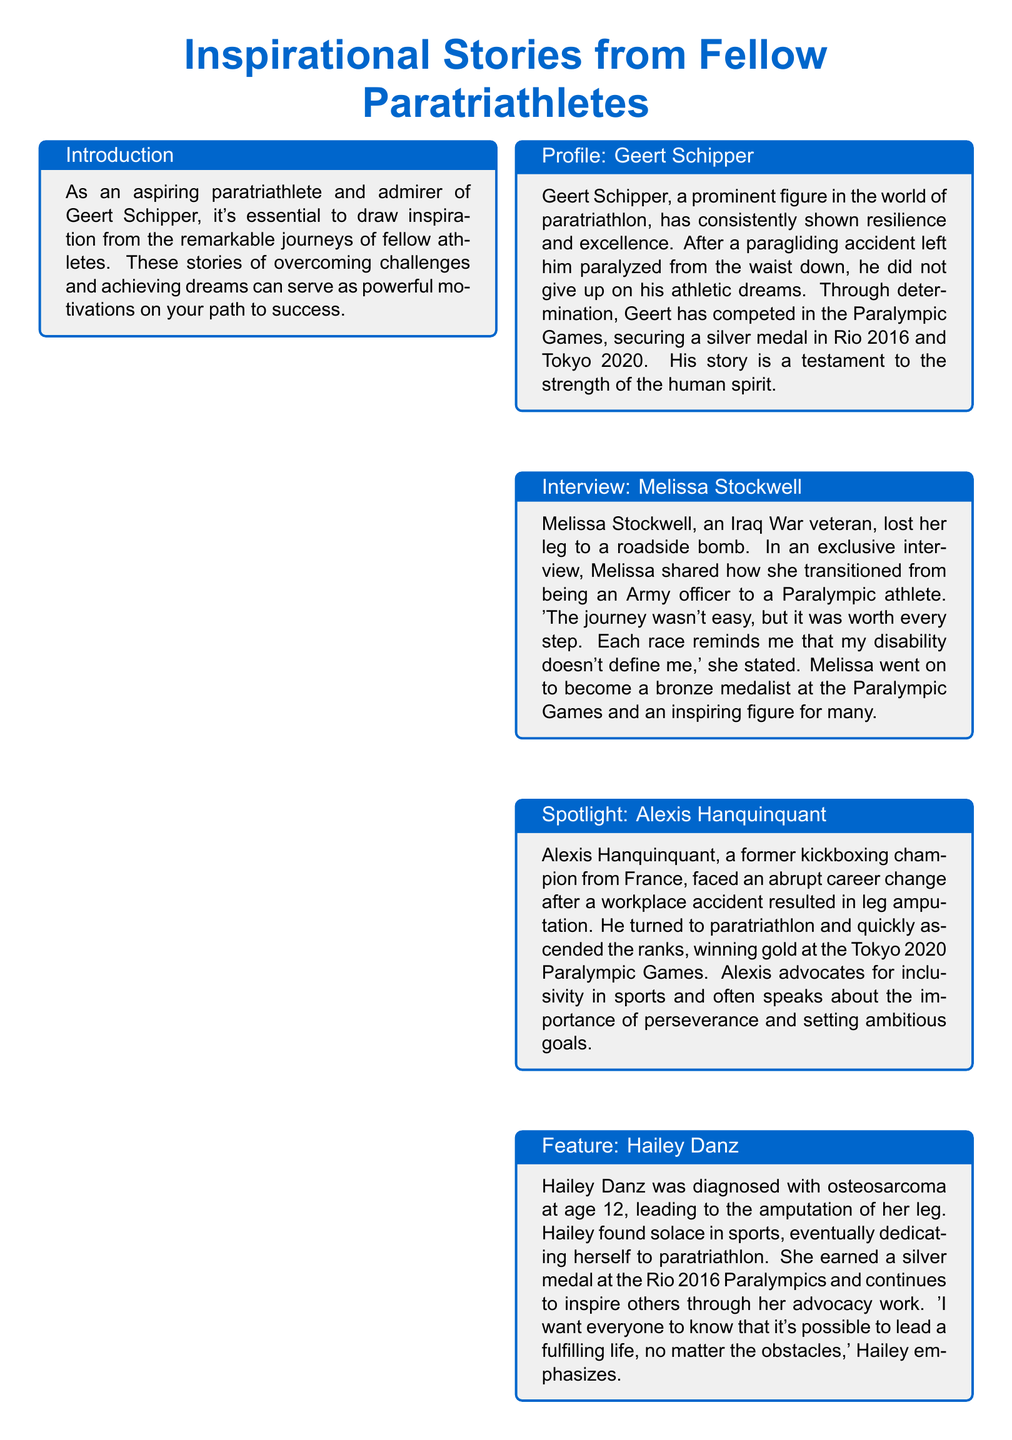What is the title of the document? The title is prominently displayed in the header and establishes the main theme of the document.
Answer: Inspirational Stories from Fellow Paratriathletes Who is featured in the profile section? The profile section focuses on a notable paratriathlete and includes key achievements and background.
Answer: Geert Schipper What major event did Melissa Stockwell compete in? The document mentions her accomplishments, including a particular event where she earned a medal.
Answer: Paralympic Games How many medals did Geert Schipper win at the Paralympic Games? The profile provides specific details about the number of medals he achieved during the events.
Answer: Two What significant challenge did Hailey Danz face at age 12? The document outlines her health struggle that led to a major life change.
Answer: Osteosarcoma Which athlete won gold at the Tokyo 2020 Paralympic Games? This question refers to the achievements of a specific athlete mentioned in the document.
Answer: Alexis Hanquinquant What is one predominant theme in the document? The conclusion ties together the narratives of the athletes and highlights a central message.
Answer: Resilience What inspired Melissa Stockwell to pursue athletics? The interview captures her personal motivation and perspective on disability.
Answer: Her journey 